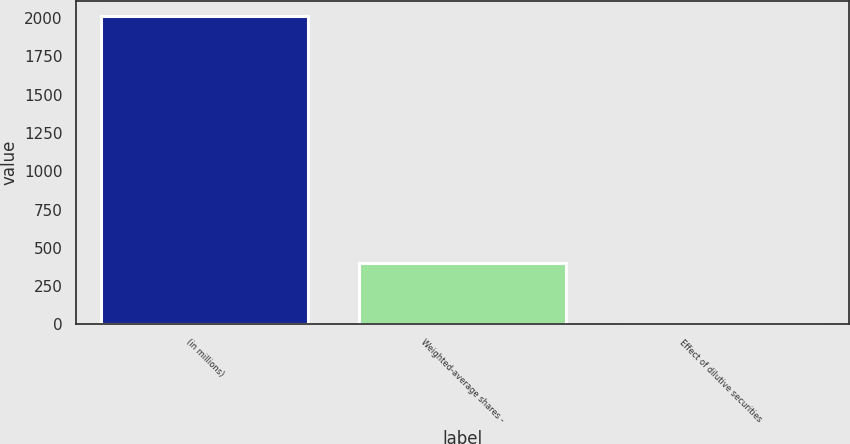Convert chart to OTSL. <chart><loc_0><loc_0><loc_500><loc_500><bar_chart><fcel>(in millions)<fcel>Weighted-average shares -<fcel>Effect of dilutive securities<nl><fcel>2012<fcel>402.96<fcel>0.7<nl></chart> 